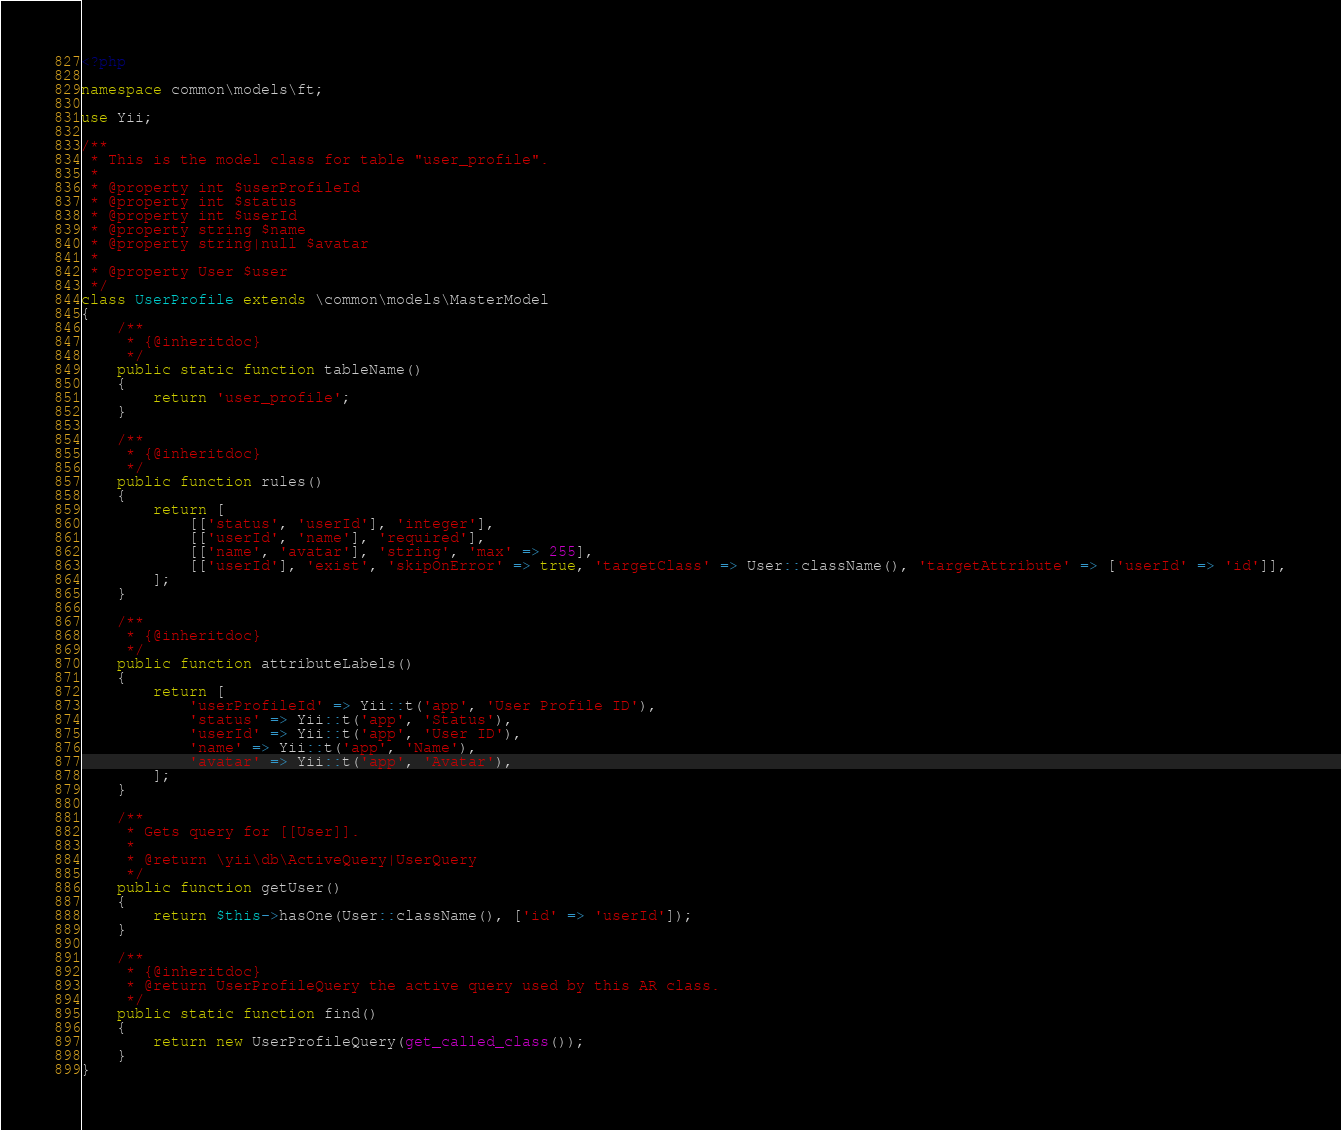Convert code to text. <code><loc_0><loc_0><loc_500><loc_500><_PHP_><?php

namespace common\models\ft;

use Yii;

/**
 * This is the model class for table "user_profile".
 *
 * @property int $userProfileId
 * @property int $status
 * @property int $userId
 * @property string $name
 * @property string|null $avatar
 *
 * @property User $user
 */
class UserProfile extends \common\models\MasterModel
{
    /**
     * {@inheritdoc}
     */
    public static function tableName()
    {
        return 'user_profile';
    }

    /**
     * {@inheritdoc}
     */
    public function rules()
    {
        return [
            [['status', 'userId'], 'integer'],
            [['userId', 'name'], 'required'],
            [['name', 'avatar'], 'string', 'max' => 255],
            [['userId'], 'exist', 'skipOnError' => true, 'targetClass' => User::className(), 'targetAttribute' => ['userId' => 'id']],
        ];
    }

    /**
     * {@inheritdoc}
     */
    public function attributeLabels()
    {
        return [
            'userProfileId' => Yii::t('app', 'User Profile ID'),
            'status' => Yii::t('app', 'Status'),
            'userId' => Yii::t('app', 'User ID'),
            'name' => Yii::t('app', 'Name'),
            'avatar' => Yii::t('app', 'Avatar'),
        ];
    }

    /**
     * Gets query for [[User]].
     *
     * @return \yii\db\ActiveQuery|UserQuery
     */
    public function getUser()
    {
        return $this->hasOne(User::className(), ['id' => 'userId']);
    }

    /**
     * {@inheritdoc}
     * @return UserProfileQuery the active query used by this AR class.
     */
    public static function find()
    {
        return new UserProfileQuery(get_called_class());
    }
}
</code> 